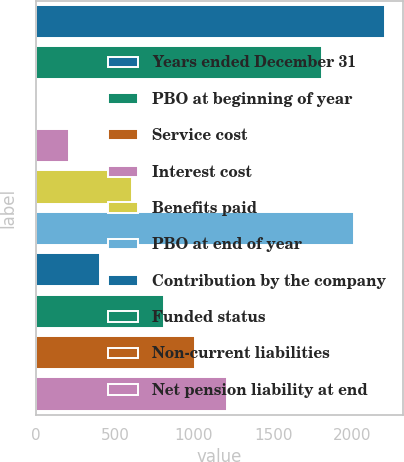Convert chart. <chart><loc_0><loc_0><loc_500><loc_500><bar_chart><fcel>Years ended December 31<fcel>PBO at beginning of year<fcel>Service cost<fcel>Interest cost<fcel>Benefits paid<fcel>PBO at end of year<fcel>Contribution by the company<fcel>Funded status<fcel>Non-current liabilities<fcel>Net pension liability at end<nl><fcel>2209.06<fcel>1808.94<fcel>8.4<fcel>208.46<fcel>608.58<fcel>2009<fcel>408.52<fcel>808.64<fcel>1008.7<fcel>1208.76<nl></chart> 